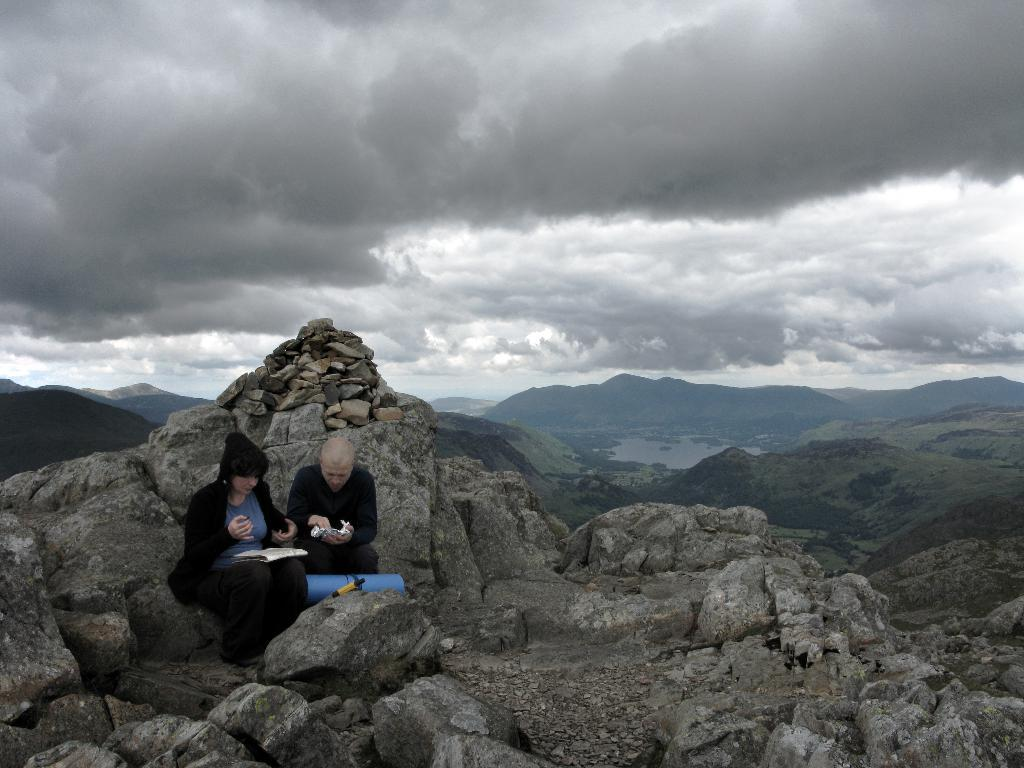How many people are present in the image? There are two people sitting in the image. What are the people holding in their hands? The people are holding objects in their hands. What can be seen in the distance behind the people? There are mountains visible in the background of the image. What else is visible in the background of the image? The sky is visible in the background of the image. What type of lumber is being used to build the baby's crib in the image? There is no lumber or baby's crib present in the image. What color is the bean that the people are holding in their hands? The objects held by the people in the image are not specified as beans, and therefore their color cannot be determined. 